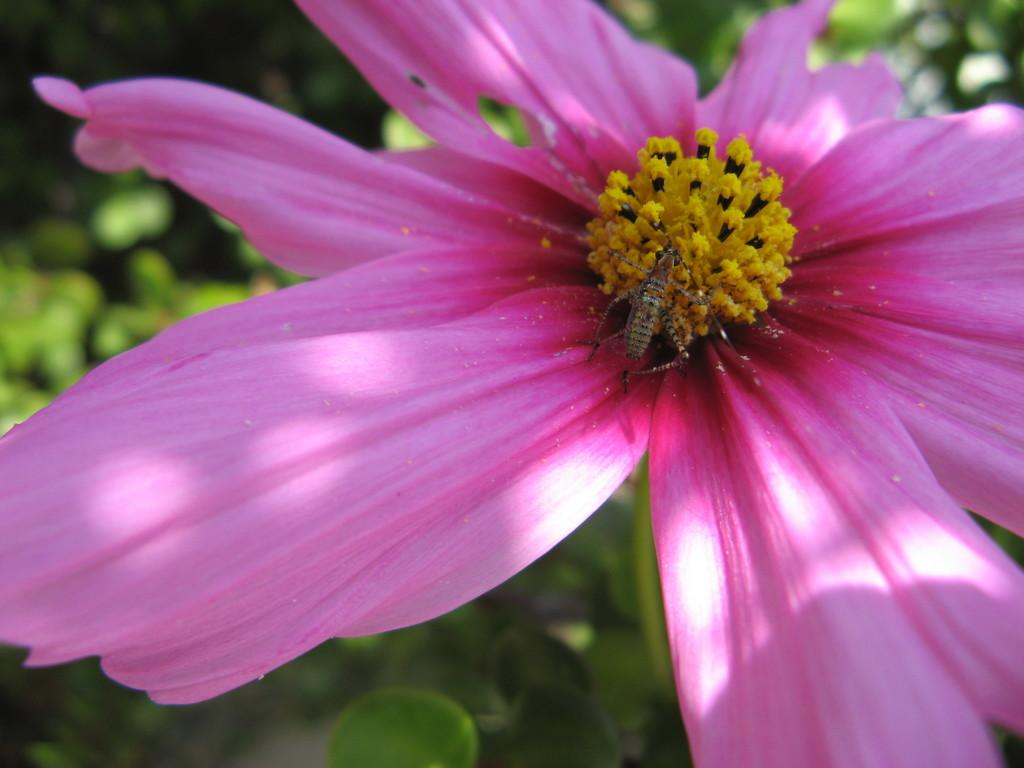What type of flower is present in the image? There is a pink color flower in the picture. Is there anything on the flower? Yes, there is an insect on the flower. What is the insect doing on the flower? The insect is on pollen grains. What can be seen in the background of the picture? There are plants in the background of the picture. What type of stocking can be seen hanging from the flower in the image? There is no stocking present in the image; it features a flower with an insect on pollen grains. How does the flower express its feelings of hate towards the insect in the image? The flower is a non-living object and does not have feelings or the ability to express emotions like hate. 